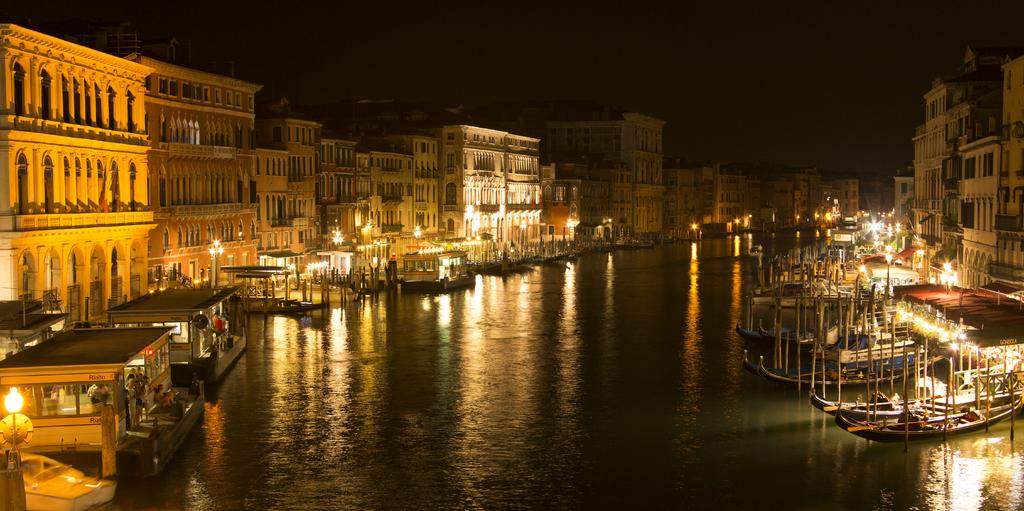Who or what is present in the image? There are people in the image. What can be seen on the river in the image? There are ships on the river in the image. What type of structures are visible in the image? There are buildings in the image. What objects have lights in the image? There are lights in the image. What are the tall, thin objects in the image? There are poles in the image. How would you describe the overall lighting in the image? The background of the image is dark. What type of fuel is being used by the airplane in the image? There is no airplane present in the image, so it is not possible to determine what type of fuel is being used. What book is the person reading in the image? There is no book visible in the image, and no one is shown reading. 